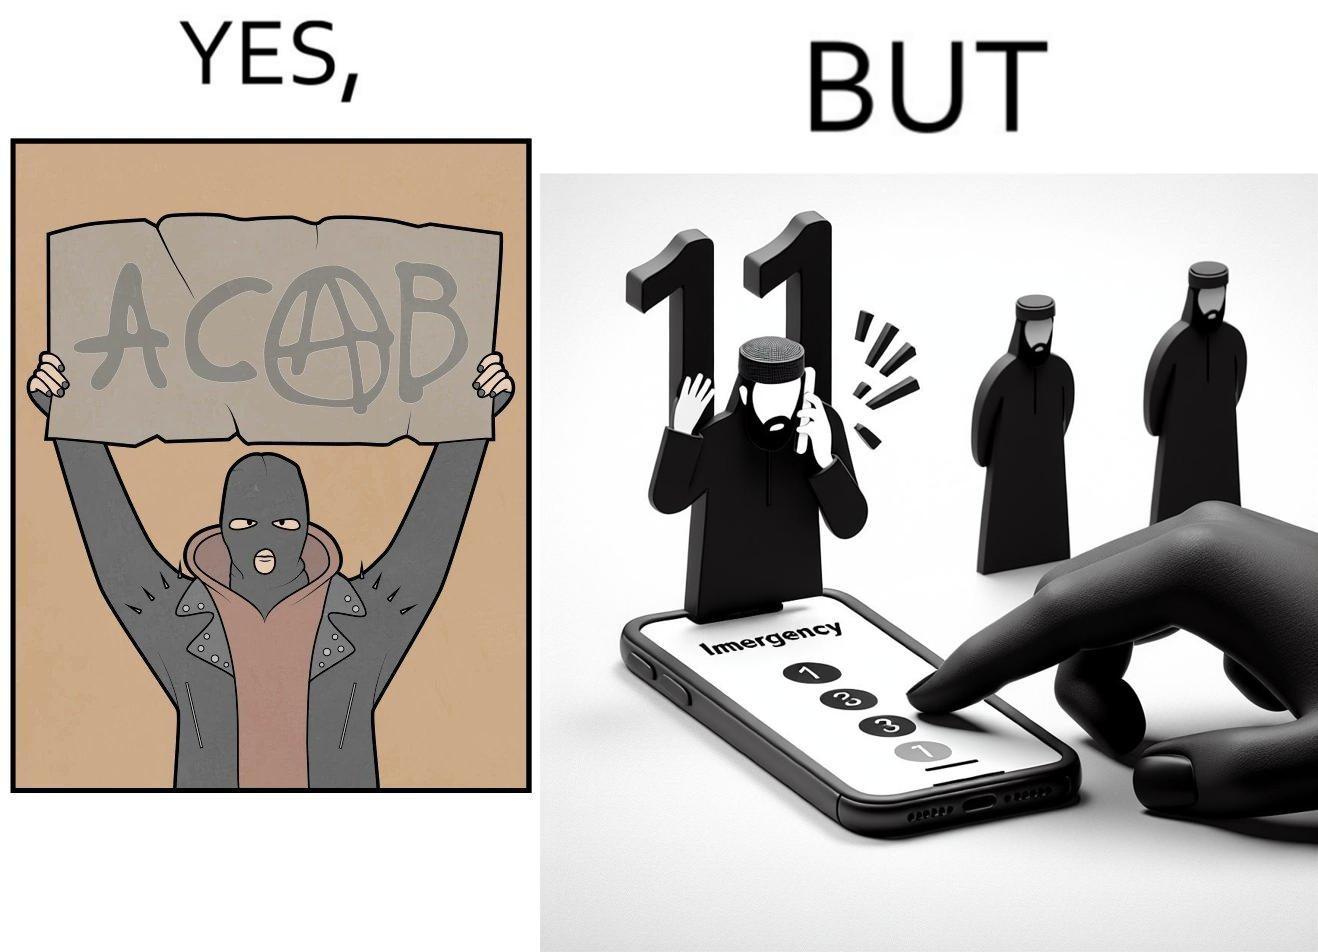Describe the content of this image. This is funny because on the one hand this person is rebelling against cops (slogan being All Cops Are Bad - ACAB), but on the other hand they are also calling the cops for help. 